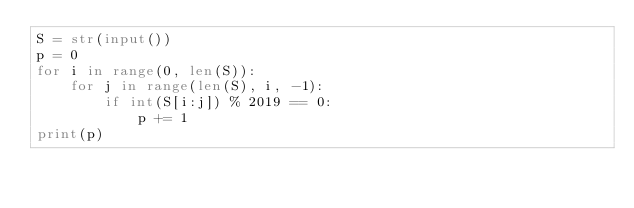Convert code to text. <code><loc_0><loc_0><loc_500><loc_500><_Python_>S = str(input())
p = 0
for i in range(0, len(S)):
    for j in range(len(S), i, -1):
        if int(S[i:j]) % 2019 == 0:
            p += 1
print(p)</code> 